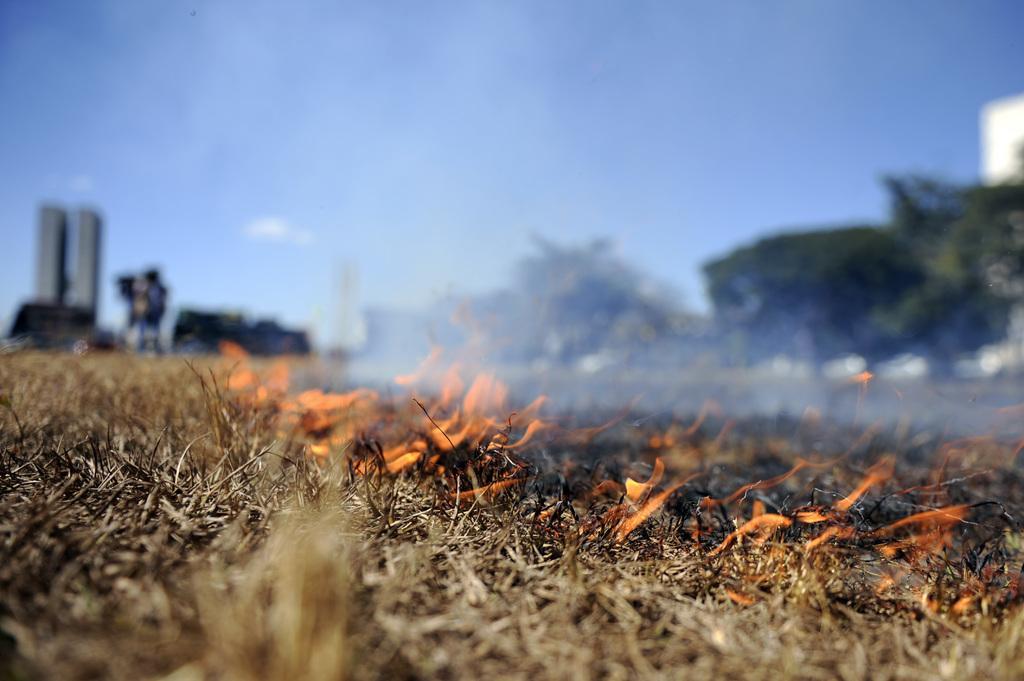Can you describe this image briefly? This picture is clicked outside the city. In the foreground we can see the dry stems and the flame. The background of the image is blur and we can see the sky, trees, buildings and some other objects in the background. 